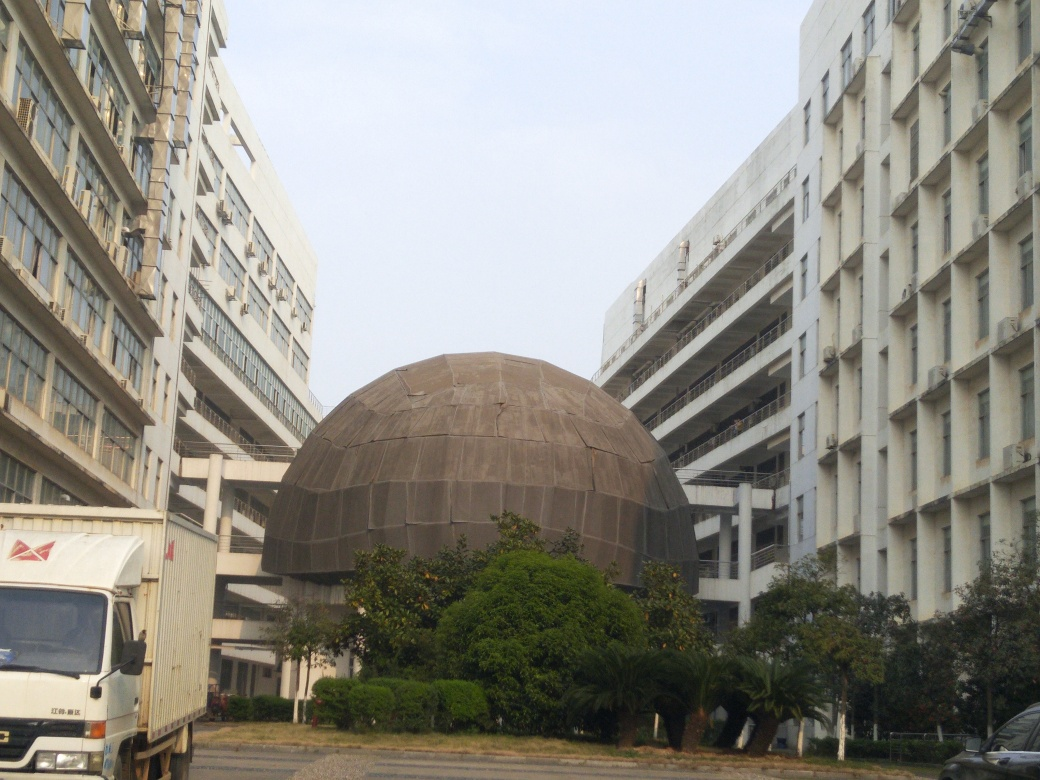Are there any quality issues with this image? Yes, there are several quality issues with the image. Specifically, the image appears somewhat washed out, potentially due to overexposure, which affects color depth and contrast. Additionally, the photo seems to lack sharpness, which could be attributed to a low camera resolution or slight motion blur. The composition could also be improved for a more engaging perspective as the subject—the dome-shaped structure—is not well-centered and the surrounding buildings are somewhat distracting. 